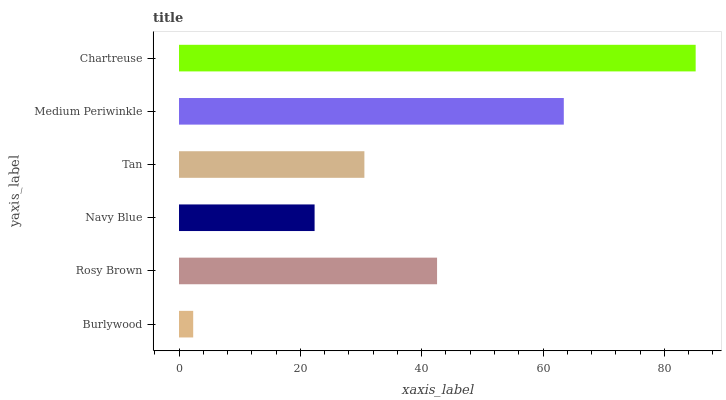Is Burlywood the minimum?
Answer yes or no. Yes. Is Chartreuse the maximum?
Answer yes or no. Yes. Is Rosy Brown the minimum?
Answer yes or no. No. Is Rosy Brown the maximum?
Answer yes or no. No. Is Rosy Brown greater than Burlywood?
Answer yes or no. Yes. Is Burlywood less than Rosy Brown?
Answer yes or no. Yes. Is Burlywood greater than Rosy Brown?
Answer yes or no. No. Is Rosy Brown less than Burlywood?
Answer yes or no. No. Is Rosy Brown the high median?
Answer yes or no. Yes. Is Tan the low median?
Answer yes or no. Yes. Is Burlywood the high median?
Answer yes or no. No. Is Burlywood the low median?
Answer yes or no. No. 